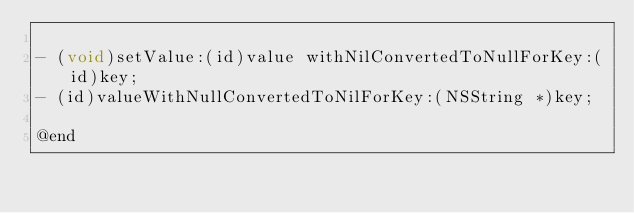<code> <loc_0><loc_0><loc_500><loc_500><_C_>
- (void)setValue:(id)value withNilConvertedToNullForKey:(id)key;
- (id)valueWithNullConvertedToNilForKey:(NSString *)key;

@end</code> 